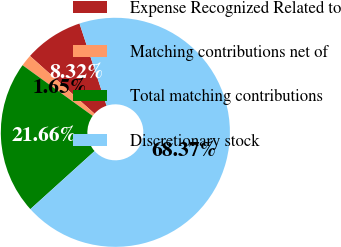<chart> <loc_0><loc_0><loc_500><loc_500><pie_chart><fcel>Expense Recognized Related to<fcel>Matching contributions net of<fcel>Total matching contributions<fcel>Discretionary stock<nl><fcel>8.32%<fcel>1.65%<fcel>21.66%<fcel>68.37%<nl></chart> 